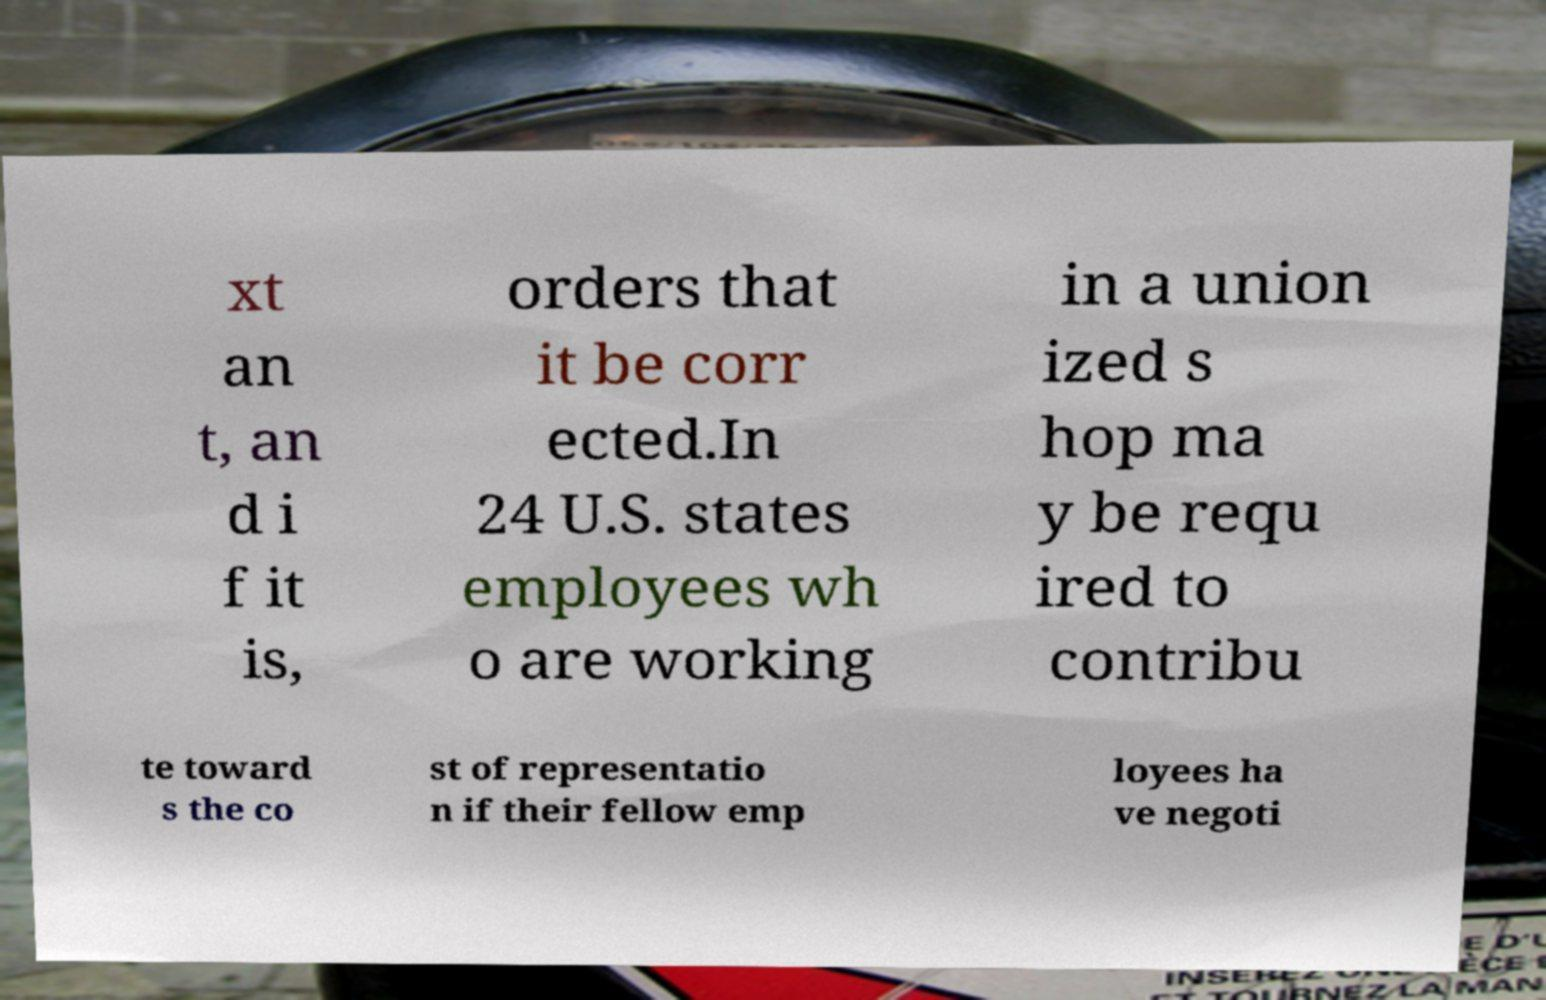I need the written content from this picture converted into text. Can you do that? xt an t, an d i f it is, orders that it be corr ected.In 24 U.S. states employees wh o are working in a union ized s hop ma y be requ ired to contribu te toward s the co st of representatio n if their fellow emp loyees ha ve negoti 